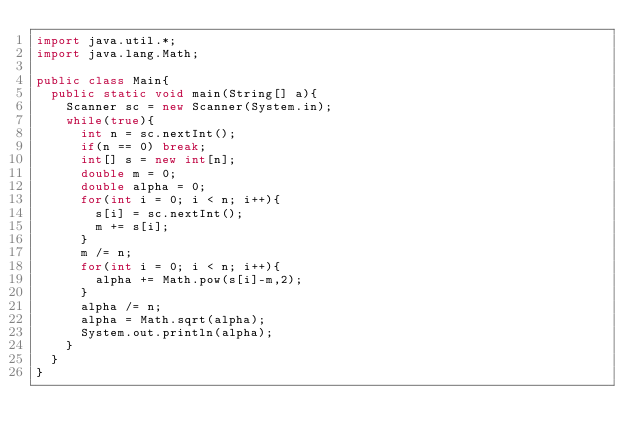<code> <loc_0><loc_0><loc_500><loc_500><_Java_>import java.util.*;
import java.lang.Math;

public class Main{
	public static void main(String[] a){
		Scanner sc = new Scanner(System.in);
		while(true){
			int n = sc.nextInt();
			if(n == 0) break;
			int[] s = new int[n];
			double m = 0;
			double alpha = 0;
			for(int i = 0; i < n; i++){
				s[i] = sc.nextInt();
				m += s[i];
			}
			m /= n;
			for(int i = 0; i < n; i++){
				alpha += Math.pow(s[i]-m,2);
			}
			alpha /= n;
			alpha = Math.sqrt(alpha);
			System.out.println(alpha);
		}
	}
}</code> 